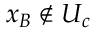<formula> <loc_0><loc_0><loc_500><loc_500>x _ { B } \notin U _ { c }</formula> 